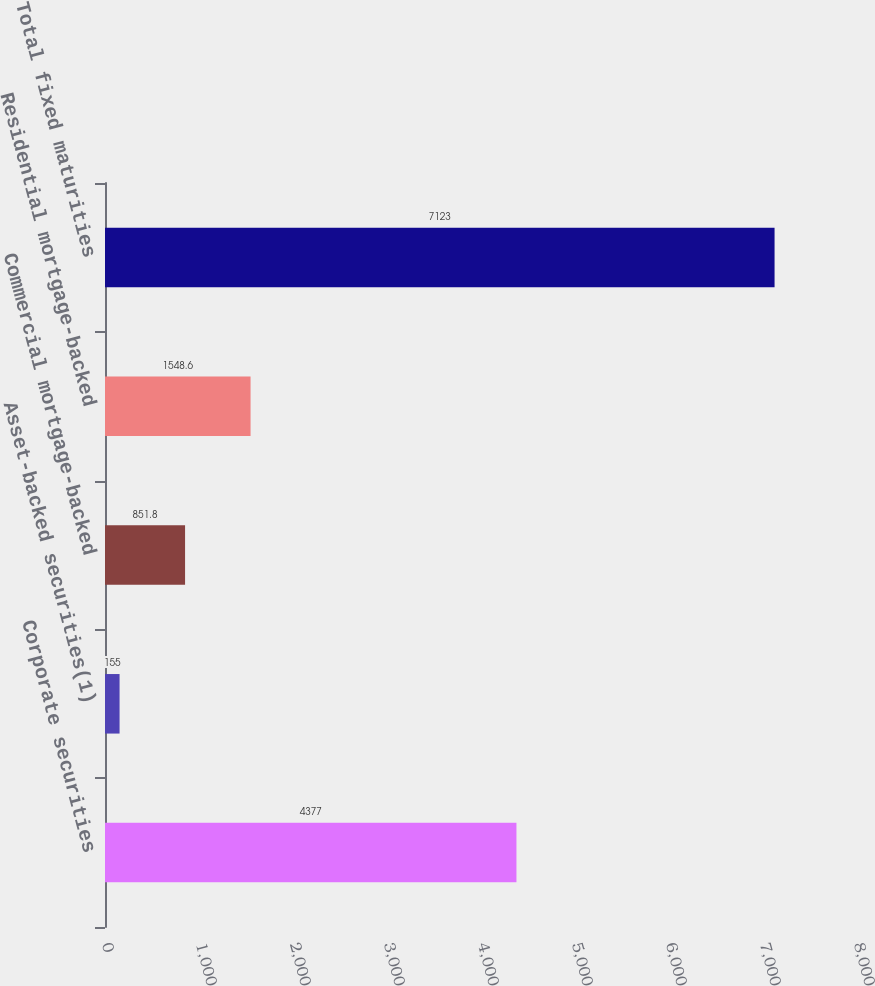Convert chart to OTSL. <chart><loc_0><loc_0><loc_500><loc_500><bar_chart><fcel>Corporate securities<fcel>Asset-backed securities(1)<fcel>Commercial mortgage-backed<fcel>Residential mortgage-backed<fcel>Total fixed maturities<nl><fcel>4377<fcel>155<fcel>851.8<fcel>1548.6<fcel>7123<nl></chart> 